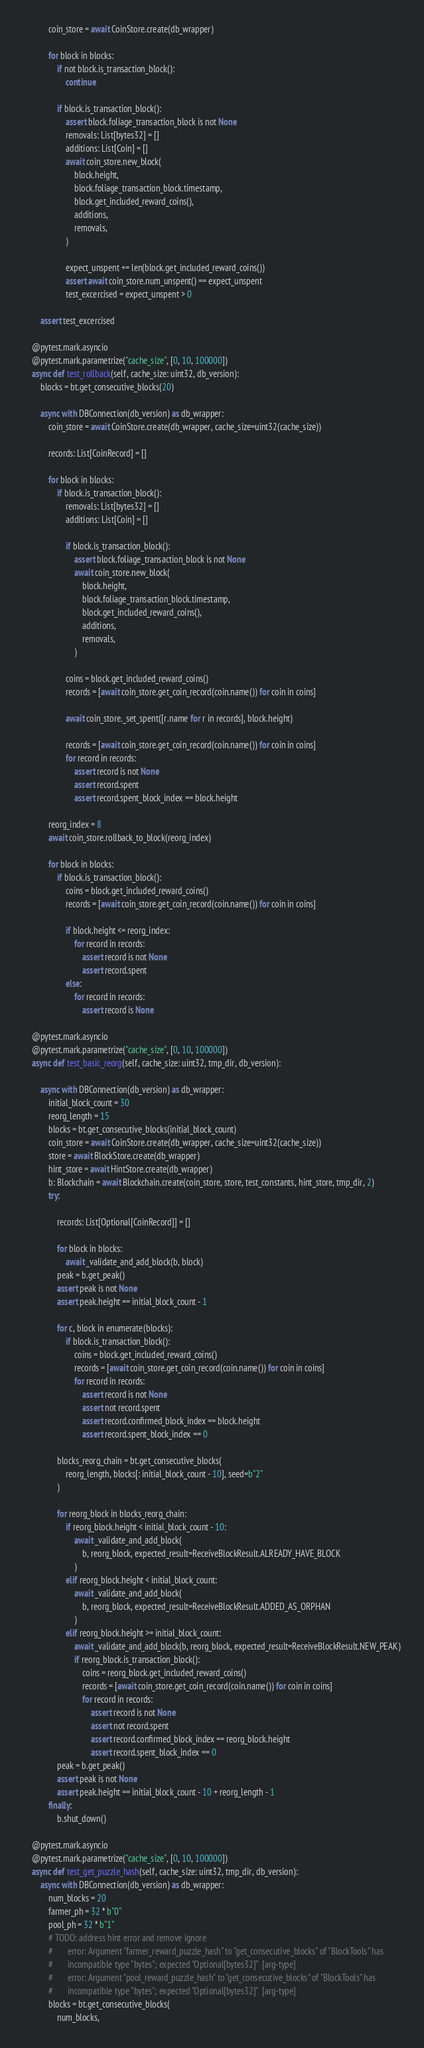<code> <loc_0><loc_0><loc_500><loc_500><_Python_>            coin_store = await CoinStore.create(db_wrapper)

            for block in blocks:
                if not block.is_transaction_block():
                    continue

                if block.is_transaction_block():
                    assert block.foliage_transaction_block is not None
                    removals: List[bytes32] = []
                    additions: List[Coin] = []
                    await coin_store.new_block(
                        block.height,
                        block.foliage_transaction_block.timestamp,
                        block.get_included_reward_coins(),
                        additions,
                        removals,
                    )

                    expect_unspent += len(block.get_included_reward_coins())
                    assert await coin_store.num_unspent() == expect_unspent
                    test_excercised = expect_unspent > 0

        assert test_excercised

    @pytest.mark.asyncio
    @pytest.mark.parametrize("cache_size", [0, 10, 100000])
    async def test_rollback(self, cache_size: uint32, db_version):
        blocks = bt.get_consecutive_blocks(20)

        async with DBConnection(db_version) as db_wrapper:
            coin_store = await CoinStore.create(db_wrapper, cache_size=uint32(cache_size))

            records: List[CoinRecord] = []

            for block in blocks:
                if block.is_transaction_block():
                    removals: List[bytes32] = []
                    additions: List[Coin] = []

                    if block.is_transaction_block():
                        assert block.foliage_transaction_block is not None
                        await coin_store.new_block(
                            block.height,
                            block.foliage_transaction_block.timestamp,
                            block.get_included_reward_coins(),
                            additions,
                            removals,
                        )

                    coins = block.get_included_reward_coins()
                    records = [await coin_store.get_coin_record(coin.name()) for coin in coins]

                    await coin_store._set_spent([r.name for r in records], block.height)

                    records = [await coin_store.get_coin_record(coin.name()) for coin in coins]
                    for record in records:
                        assert record is not None
                        assert record.spent
                        assert record.spent_block_index == block.height

            reorg_index = 8
            await coin_store.rollback_to_block(reorg_index)

            for block in blocks:
                if block.is_transaction_block():
                    coins = block.get_included_reward_coins()
                    records = [await coin_store.get_coin_record(coin.name()) for coin in coins]

                    if block.height <= reorg_index:
                        for record in records:
                            assert record is not None
                            assert record.spent
                    else:
                        for record in records:
                            assert record is None

    @pytest.mark.asyncio
    @pytest.mark.parametrize("cache_size", [0, 10, 100000])
    async def test_basic_reorg(self, cache_size: uint32, tmp_dir, db_version):

        async with DBConnection(db_version) as db_wrapper:
            initial_block_count = 30
            reorg_length = 15
            blocks = bt.get_consecutive_blocks(initial_block_count)
            coin_store = await CoinStore.create(db_wrapper, cache_size=uint32(cache_size))
            store = await BlockStore.create(db_wrapper)
            hint_store = await HintStore.create(db_wrapper)
            b: Blockchain = await Blockchain.create(coin_store, store, test_constants, hint_store, tmp_dir, 2)
            try:

                records: List[Optional[CoinRecord]] = []

                for block in blocks:
                    await _validate_and_add_block(b, block)
                peak = b.get_peak()
                assert peak is not None
                assert peak.height == initial_block_count - 1

                for c, block in enumerate(blocks):
                    if block.is_transaction_block():
                        coins = block.get_included_reward_coins()
                        records = [await coin_store.get_coin_record(coin.name()) for coin in coins]
                        for record in records:
                            assert record is not None
                            assert not record.spent
                            assert record.confirmed_block_index == block.height
                            assert record.spent_block_index == 0

                blocks_reorg_chain = bt.get_consecutive_blocks(
                    reorg_length, blocks[: initial_block_count - 10], seed=b"2"
                )

                for reorg_block in blocks_reorg_chain:
                    if reorg_block.height < initial_block_count - 10:
                        await _validate_and_add_block(
                            b, reorg_block, expected_result=ReceiveBlockResult.ALREADY_HAVE_BLOCK
                        )
                    elif reorg_block.height < initial_block_count:
                        await _validate_and_add_block(
                            b, reorg_block, expected_result=ReceiveBlockResult.ADDED_AS_ORPHAN
                        )
                    elif reorg_block.height >= initial_block_count:
                        await _validate_and_add_block(b, reorg_block, expected_result=ReceiveBlockResult.NEW_PEAK)
                        if reorg_block.is_transaction_block():
                            coins = reorg_block.get_included_reward_coins()
                            records = [await coin_store.get_coin_record(coin.name()) for coin in coins]
                            for record in records:
                                assert record is not None
                                assert not record.spent
                                assert record.confirmed_block_index == reorg_block.height
                                assert record.spent_block_index == 0
                peak = b.get_peak()
                assert peak is not None
                assert peak.height == initial_block_count - 10 + reorg_length - 1
            finally:
                b.shut_down()

    @pytest.mark.asyncio
    @pytest.mark.parametrize("cache_size", [0, 10, 100000])
    async def test_get_puzzle_hash(self, cache_size: uint32, tmp_dir, db_version):
        async with DBConnection(db_version) as db_wrapper:
            num_blocks = 20
            farmer_ph = 32 * b"0"
            pool_ph = 32 * b"1"
            # TODO: address hint error and remove ignore
            #       error: Argument "farmer_reward_puzzle_hash" to "get_consecutive_blocks" of "BlockTools" has
            #       incompatible type "bytes"; expected "Optional[bytes32]"  [arg-type]
            #       error: Argument "pool_reward_puzzle_hash" to "get_consecutive_blocks" of "BlockTools" has
            #       incompatible type "bytes"; expected "Optional[bytes32]"  [arg-type]
            blocks = bt.get_consecutive_blocks(
                num_blocks,</code> 